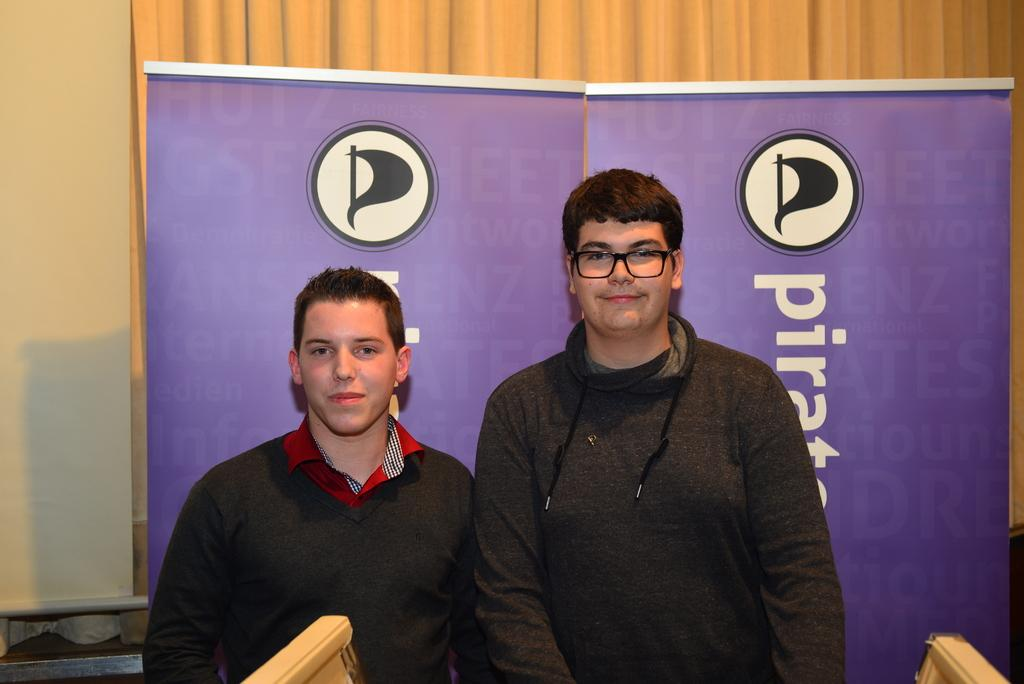How many boys are in the image? There are two boys in the image. What are the boys wearing? Both boys are wearing clothes. What expression do the boys have? The boys are smiling. Can you describe the appearance of the right side boy? The right side boy is wearing spectacles. What can be seen on the walls in the image? There are posters visible in the image. What is visible in the background of the image? There is a wall and curtains in the background of the image. What type of lamp is hanging from the throat of the left side boy? There is no lamp present in the image, and the boys' throats are not mentioned. 